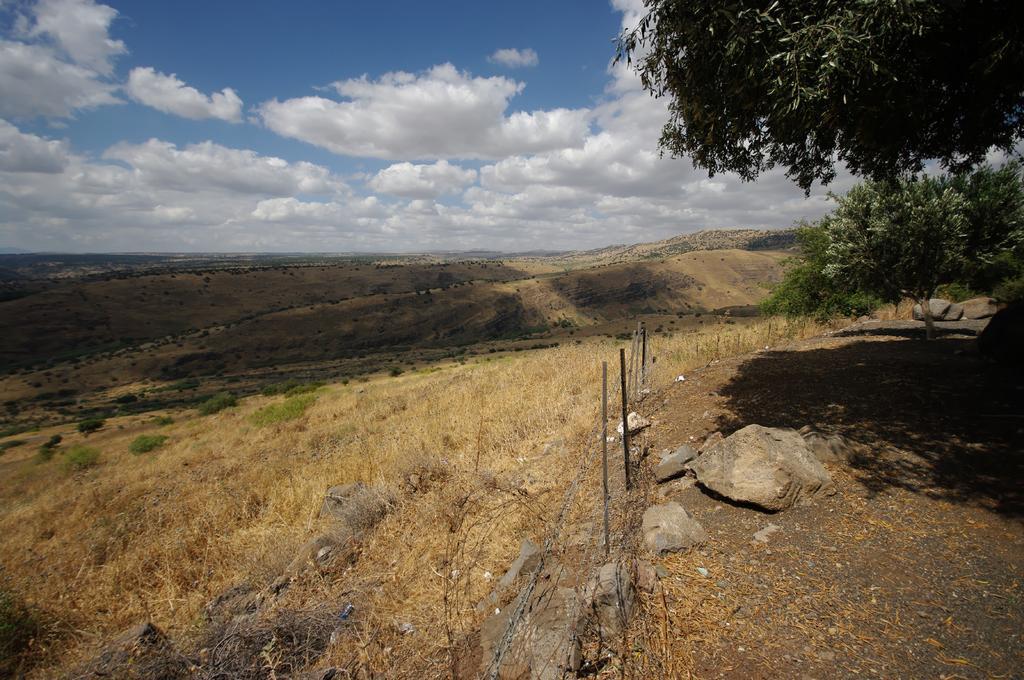How would you summarize this image in a sentence or two? This is an outside view. Here I can see few plants, grass and rocks on the ground. On the right side there are some trees. In the background, I can see the hills. At the top of the image I can see the sky and clouds. 